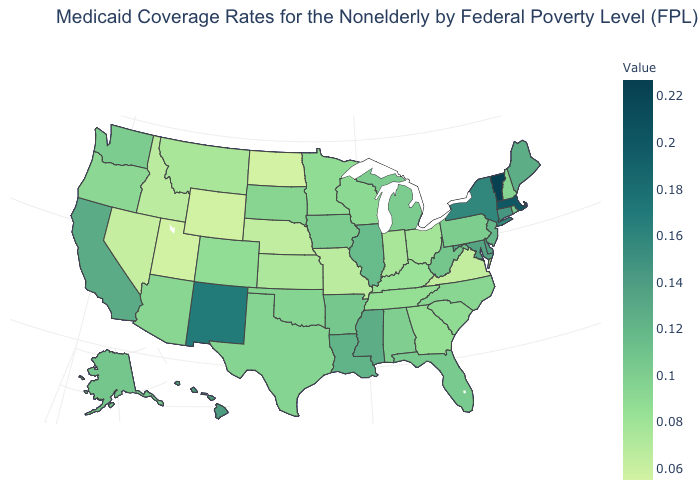Does Maryland have a lower value than Kansas?
Answer briefly. No. Does New York have a lower value than Arkansas?
Be succinct. No. Does Utah have the lowest value in the West?
Short answer required. Yes. Which states have the lowest value in the South?
Be succinct. Virginia. Does Kansas have a higher value than West Virginia?
Give a very brief answer. No. 